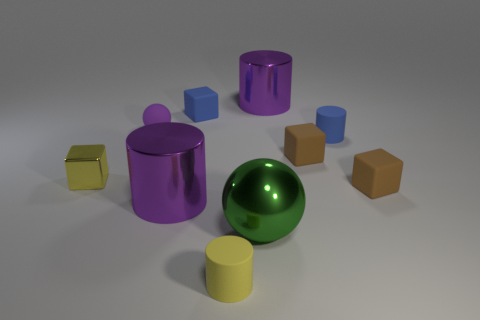There is a tiny thing that is made of the same material as the big green sphere; what is its color?
Give a very brief answer. Yellow. What is the color of the shiny cylinder that is in front of the purple thing to the right of the tiny blue thing that is behind the rubber sphere?
Keep it short and to the point. Purple. What number of cubes are purple things or brown things?
Give a very brief answer. 2. What is the material of the tiny cylinder that is the same color as the tiny metal cube?
Your response must be concise. Rubber. Does the tiny shiny cube have the same color as the sphere that is behind the tiny yellow metallic thing?
Keep it short and to the point. No. The tiny rubber sphere has what color?
Keep it short and to the point. Purple. How many things are either small yellow cubes or brown blocks?
Make the answer very short. 3. There is a sphere that is the same size as the yellow cylinder; what is its material?
Give a very brief answer. Rubber. How big is the blue object behind the tiny purple ball?
Provide a succinct answer. Small. What is the material of the small yellow block?
Provide a succinct answer. Metal. 